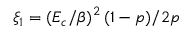Convert formula to latex. <formula><loc_0><loc_0><loc_500><loc_500>\xi _ { 1 } = ( E _ { c } / \beta ) ^ { 2 } \, ( 1 - p ) / 2 p</formula> 